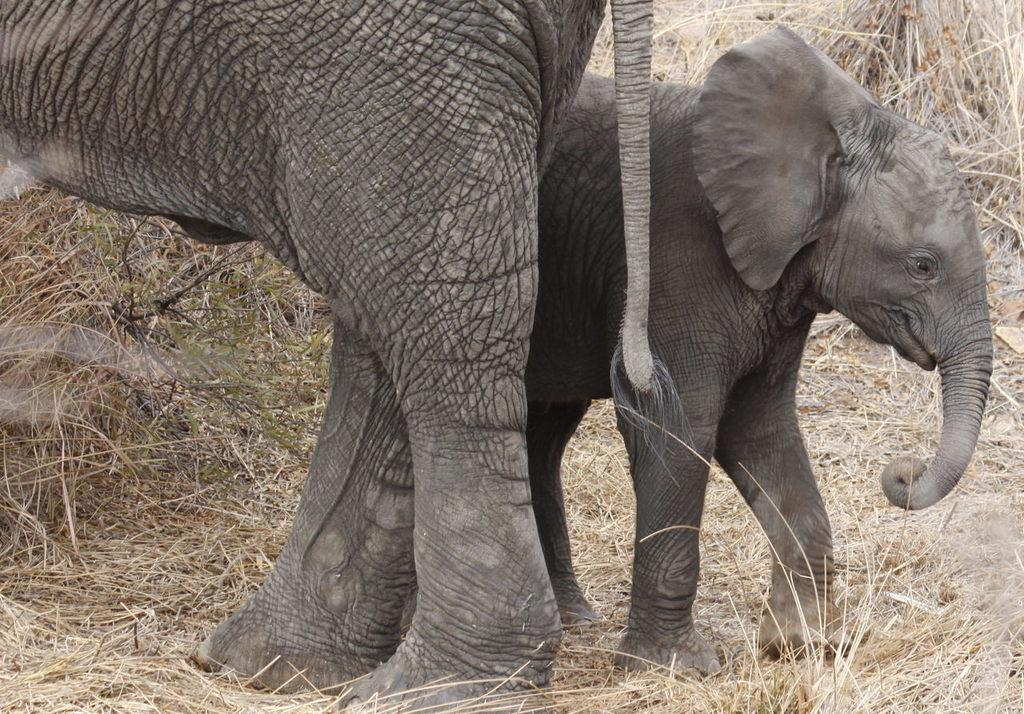What animals are present in the image? There are elephants in the image. What type of vegetation can be seen in the background of the image? There is grass visible in the background of the image. What type of cork can be seen in the image? There is no cork present in the image; it features elephants and grass. 